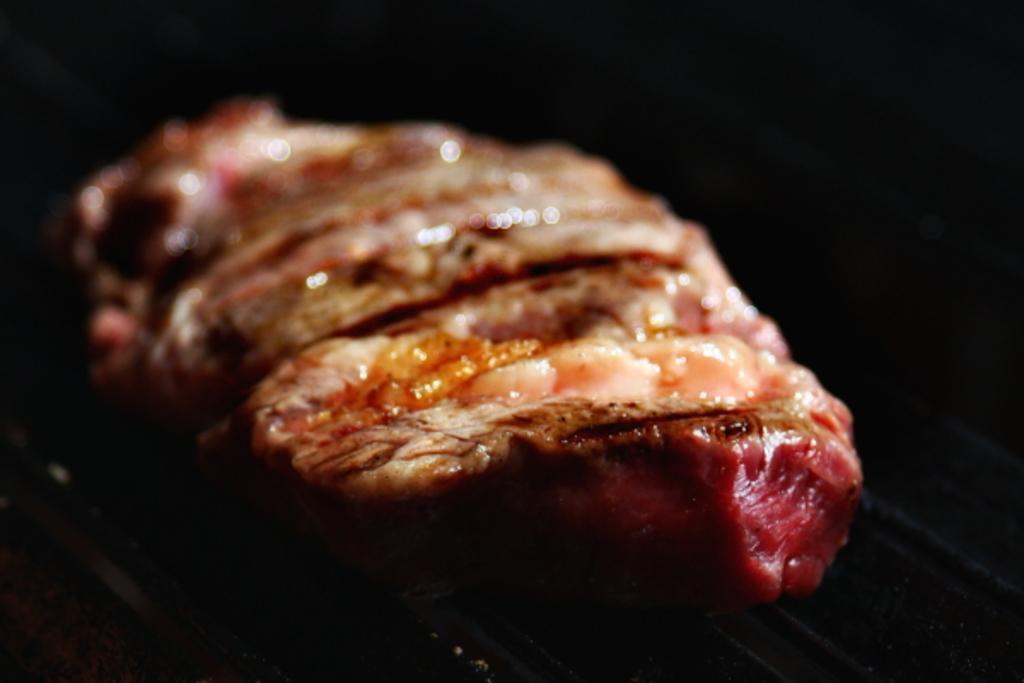Describe this image in one or two sentences. In this image we can see food item. There is a dark background. 